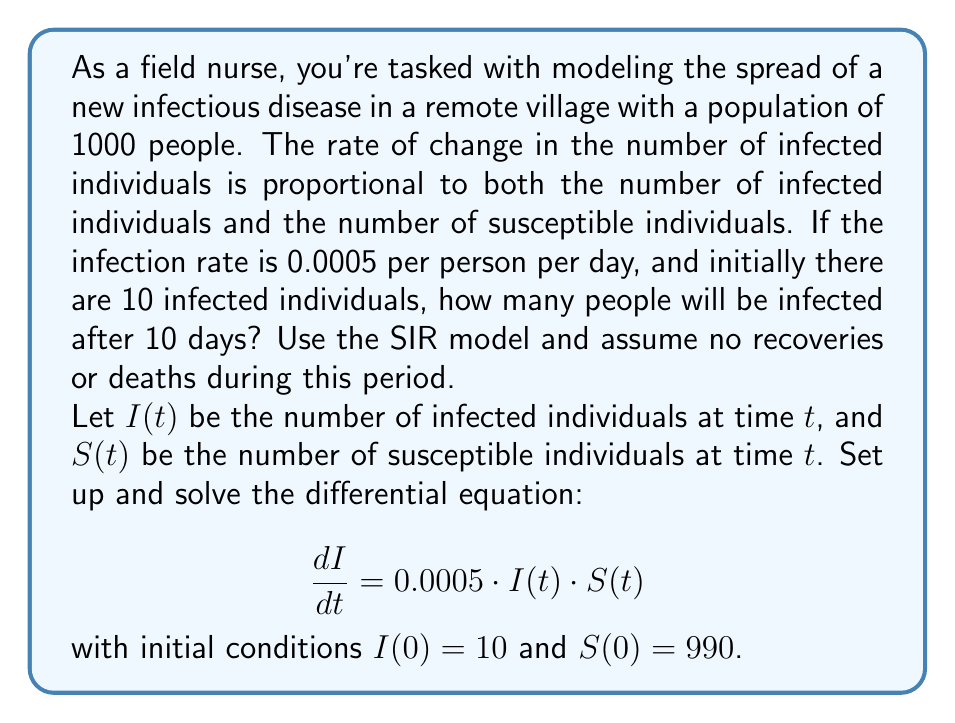Give your solution to this math problem. To solve this problem, we'll use the SIR model without the recovery component, as we're assuming no recoveries or deaths during the given period. We'll follow these steps:

1) Set up the differential equations:
   $$\frac{dS}{dt} = -0.0005 \cdot I \cdot S$$
   $$\frac{dI}{dt} = 0.0005 \cdot I \cdot S$$

2) Note that $S + I = 1000$ (total population) at all times.

3) Divide the second equation by the first:
   $$\frac{dI}{dS} = -1$$

4) Integrate both sides:
   $$I = -S + C$$

5) Use the initial conditions to find $C$:
   $10 = -990 + C$
   $C = 1000$

6) So, we have: $I = -S + 1000$ or $S = 1000 - I$

7) Substitute this into the second differential equation:
   $$\frac{dI}{dt} = 0.0005 \cdot I \cdot (1000 - I)$$

8) This is a logistic differential equation. Its solution is:
   $$I(t) = \frac{1000}{1 + 99e^{-0.5t}}$$

9) To find $I(10)$, we substitute $t = 10$:
   $$I(10) = \frac{1000}{1 + 99e^{-5}} \approx 148.41$$

10) Rounding to the nearest whole number, as we're dealing with people:
    $I(10) \approx 148$ people
Answer: After 10 days, approximately 148 people will be infected. 